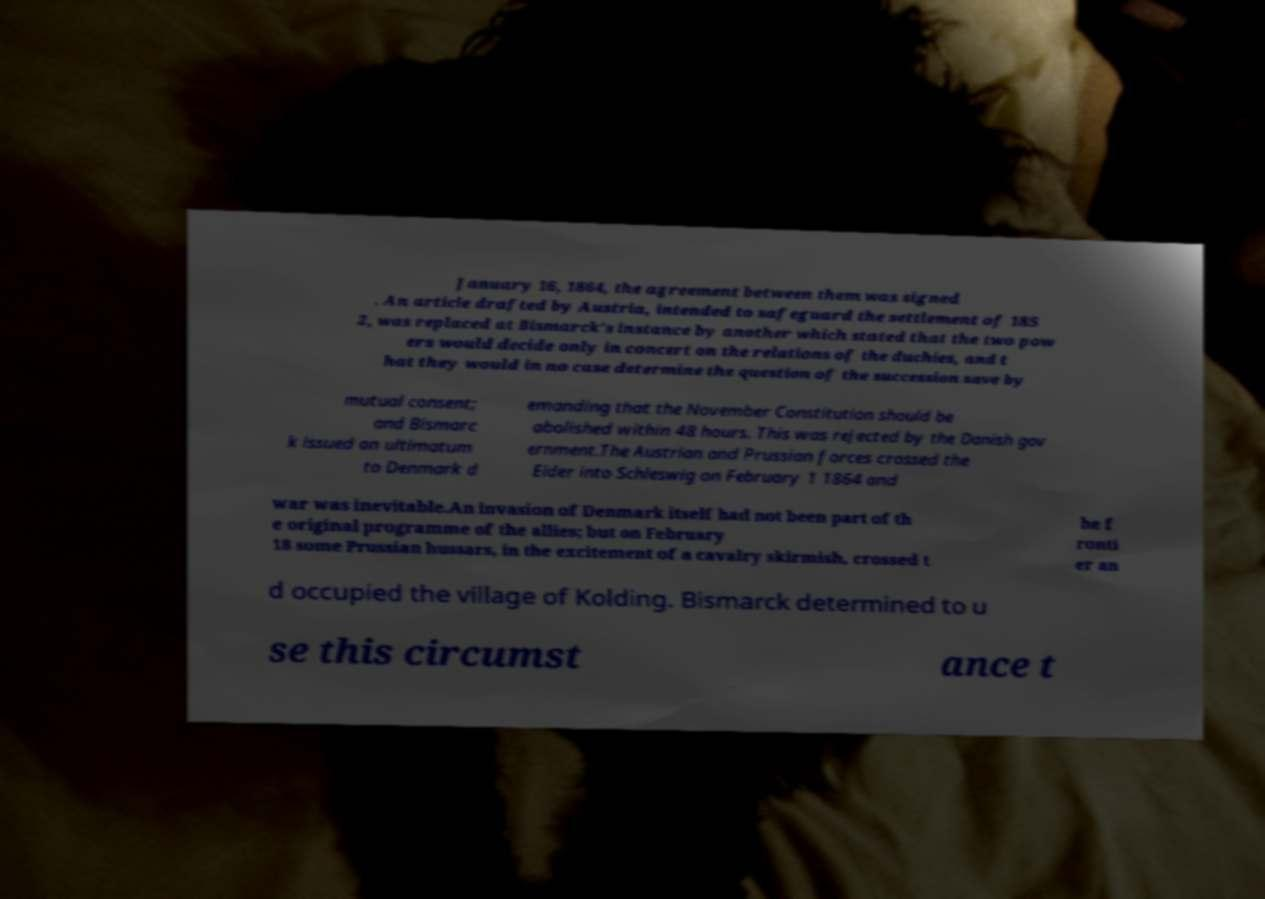There's text embedded in this image that I need extracted. Can you transcribe it verbatim? January 16, 1864, the agreement between them was signed . An article drafted by Austria, intended to safeguard the settlement of 185 2, was replaced at Bismarck's instance by another which stated that the two pow ers would decide only in concert on the relations of the duchies, and t hat they would in no case determine the question of the succession save by mutual consent; and Bismarc k issued an ultimatum to Denmark d emanding that the November Constitution should be abolished within 48 hours. This was rejected by the Danish gov ernment.The Austrian and Prussian forces crossed the Eider into Schleswig on February 1 1864 and war was inevitable.An invasion of Denmark itself had not been part of th e original programme of the allies; but on February 18 some Prussian hussars, in the excitement of a cavalry skirmish, crossed t he f ronti er an d occupied the village of Kolding. Bismarck determined to u se this circumst ance t 